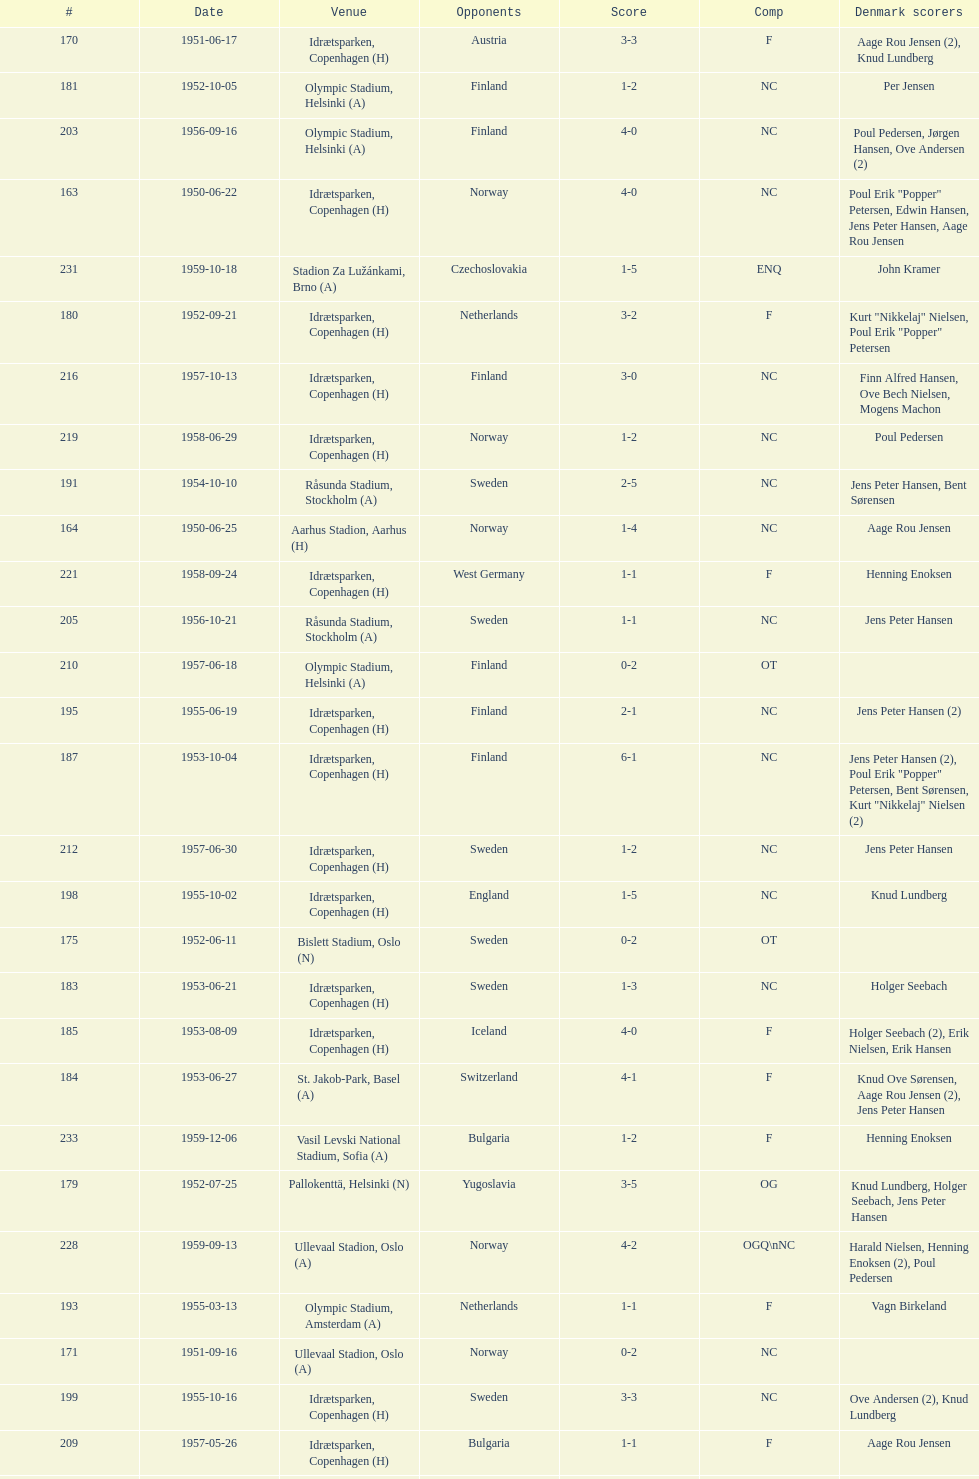Who did they play in the game listed directly above july 25, 1952? Poland. 